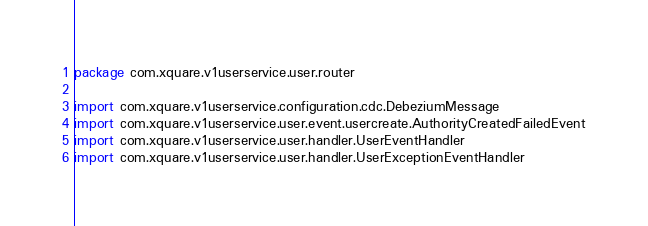<code> <loc_0><loc_0><loc_500><loc_500><_Kotlin_>package com.xquare.v1userservice.user.router

import com.xquare.v1userservice.configuration.cdc.DebeziumMessage
import com.xquare.v1userservice.user.event.usercreate.AuthorityCreatedFailedEvent
import com.xquare.v1userservice.user.handler.UserEventHandler
import com.xquare.v1userservice.user.handler.UserExceptionEventHandler</code> 